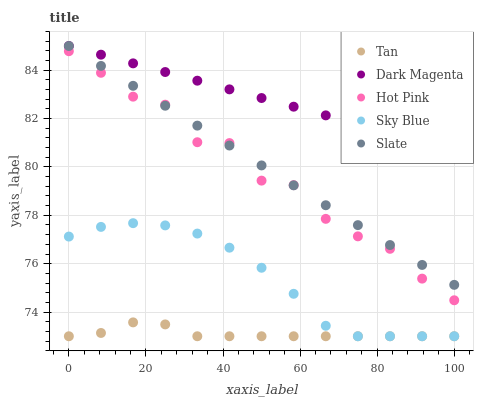Does Tan have the minimum area under the curve?
Answer yes or no. Yes. Does Dark Magenta have the maximum area under the curve?
Answer yes or no. Yes. Does Sky Blue have the minimum area under the curve?
Answer yes or no. No. Does Sky Blue have the maximum area under the curve?
Answer yes or no. No. Is Dark Magenta the smoothest?
Answer yes or no. Yes. Is Hot Pink the roughest?
Answer yes or no. Yes. Is Sky Blue the smoothest?
Answer yes or no. No. Is Sky Blue the roughest?
Answer yes or no. No. Does Sky Blue have the lowest value?
Answer yes or no. Yes. Does Hot Pink have the lowest value?
Answer yes or no. No. Does Dark Magenta have the highest value?
Answer yes or no. Yes. Does Sky Blue have the highest value?
Answer yes or no. No. Is Tan less than Dark Magenta?
Answer yes or no. Yes. Is Hot Pink greater than Tan?
Answer yes or no. Yes. Does Dark Magenta intersect Slate?
Answer yes or no. Yes. Is Dark Magenta less than Slate?
Answer yes or no. No. Is Dark Magenta greater than Slate?
Answer yes or no. No. Does Tan intersect Dark Magenta?
Answer yes or no. No. 